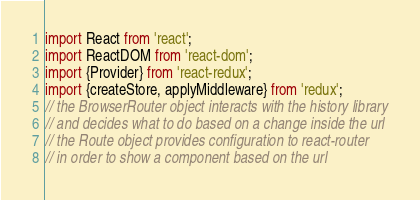Convert code to text. <code><loc_0><loc_0><loc_500><loc_500><_JavaScript_>import React from 'react';
import ReactDOM from 'react-dom';
import {Provider} from 'react-redux';
import {createStore, applyMiddleware} from 'redux';
// the BrowserRouter object interacts with the history library
// and decides what to do based on a change inside the url
// the Route object provides configuration to react-router
// in order to show a component based on the url</code> 